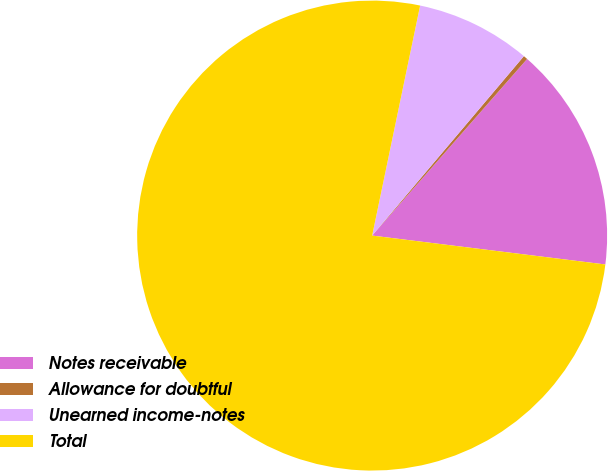Convert chart. <chart><loc_0><loc_0><loc_500><loc_500><pie_chart><fcel>Notes receivable<fcel>Allowance for doubtful<fcel>Unearned income-notes<fcel>Total<nl><fcel>15.5%<fcel>0.29%<fcel>7.9%<fcel>76.31%<nl></chart> 